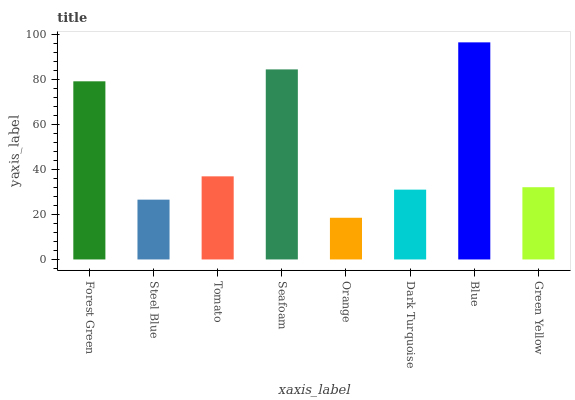Is Orange the minimum?
Answer yes or no. Yes. Is Blue the maximum?
Answer yes or no. Yes. Is Steel Blue the minimum?
Answer yes or no. No. Is Steel Blue the maximum?
Answer yes or no. No. Is Forest Green greater than Steel Blue?
Answer yes or no. Yes. Is Steel Blue less than Forest Green?
Answer yes or no. Yes. Is Steel Blue greater than Forest Green?
Answer yes or no. No. Is Forest Green less than Steel Blue?
Answer yes or no. No. Is Tomato the high median?
Answer yes or no. Yes. Is Green Yellow the low median?
Answer yes or no. Yes. Is Seafoam the high median?
Answer yes or no. No. Is Seafoam the low median?
Answer yes or no. No. 